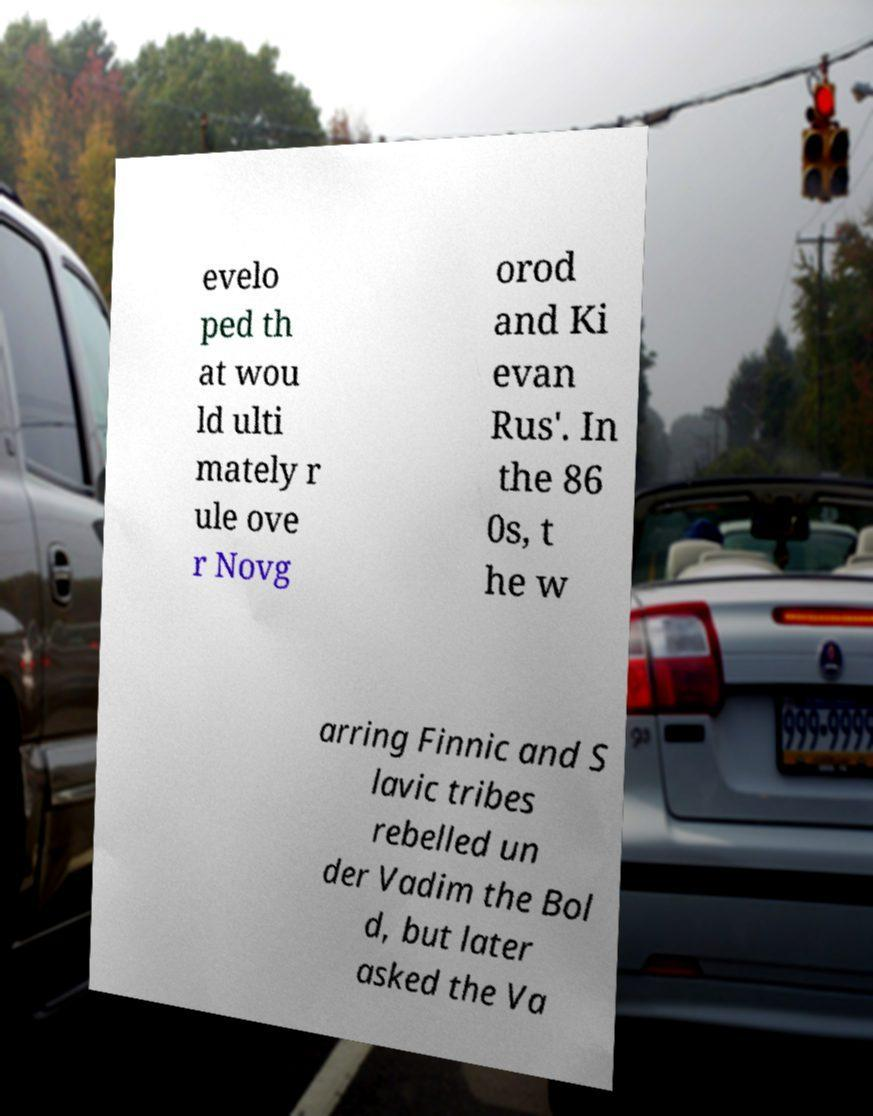What messages or text are displayed in this image? I need them in a readable, typed format. evelo ped th at wou ld ulti mately r ule ove r Novg orod and Ki evan Rus'. In the 86 0s, t he w arring Finnic and S lavic tribes rebelled un der Vadim the Bol d, but later asked the Va 